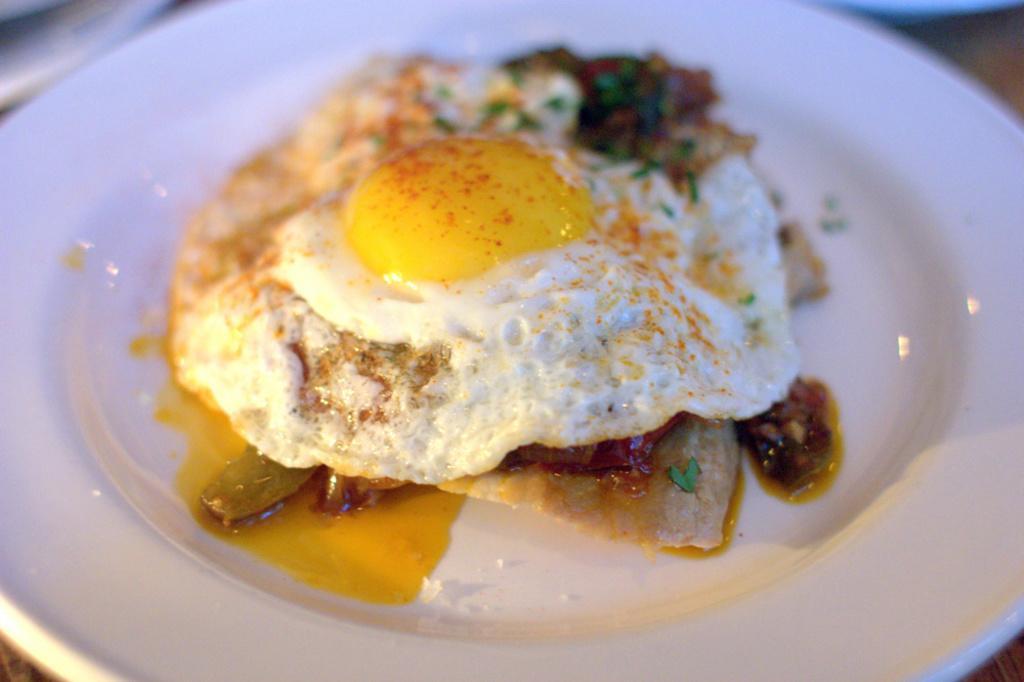Describe this image in one or two sentences. Here we can see food item and on it there is a half boiled omelette on a plate. On the left at the top corner we can see an object. 